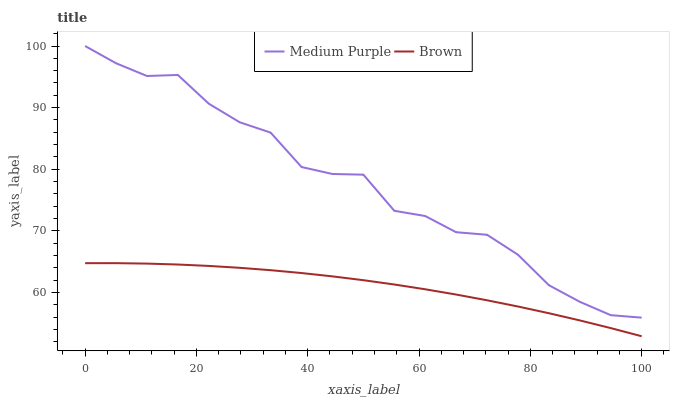Does Brown have the minimum area under the curve?
Answer yes or no. Yes. Does Medium Purple have the maximum area under the curve?
Answer yes or no. Yes. Does Brown have the maximum area under the curve?
Answer yes or no. No. Is Brown the smoothest?
Answer yes or no. Yes. Is Medium Purple the roughest?
Answer yes or no. Yes. Is Brown the roughest?
Answer yes or no. No. Does Brown have the lowest value?
Answer yes or no. Yes. Does Medium Purple have the highest value?
Answer yes or no. Yes. Does Brown have the highest value?
Answer yes or no. No. Is Brown less than Medium Purple?
Answer yes or no. Yes. Is Medium Purple greater than Brown?
Answer yes or no. Yes. Does Brown intersect Medium Purple?
Answer yes or no. No. 